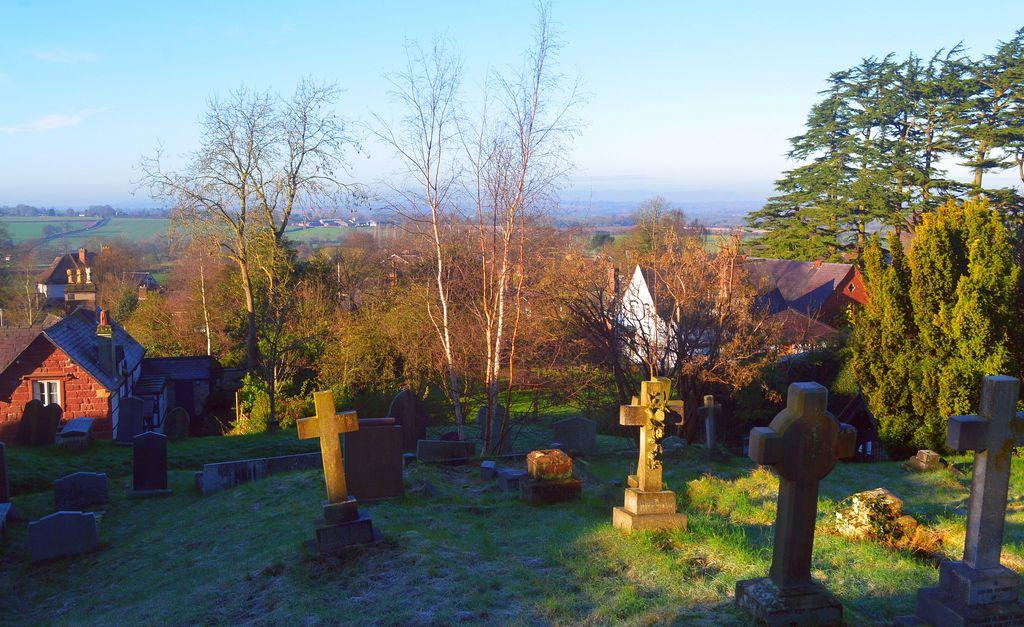What type of structures can be seen in the image? There are graves and houses in the image. What natural elements are present in the image? There are trees and grass in the image. Can you see any squirrels climbing the trees in the image? There are no squirrels visible in the image; only trees and grass are present. 